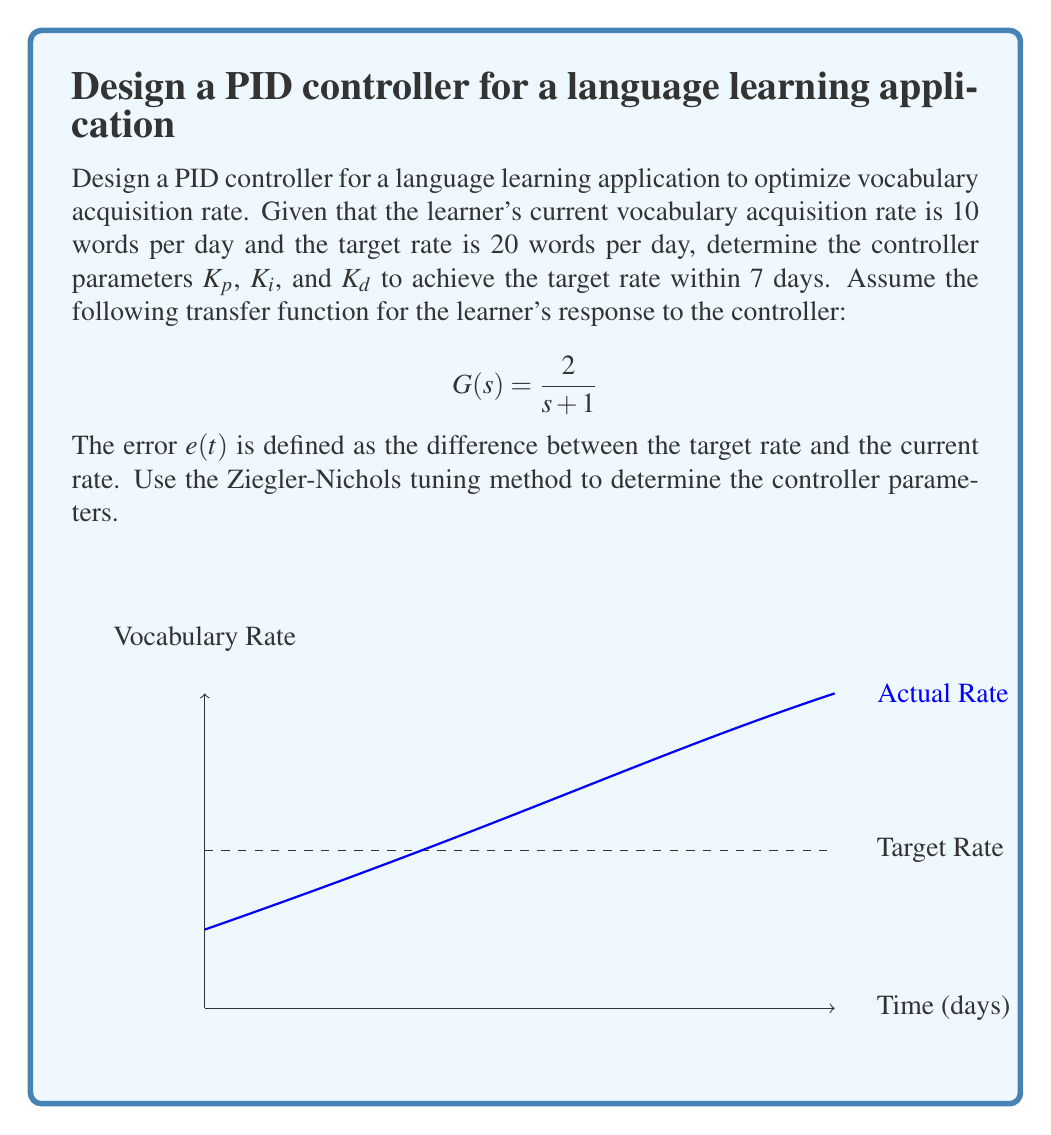Give your solution to this math problem. To design the PID controller, we'll follow these steps:

1. Determine the critical gain $K_u$ and critical period $T_u$ using the Ziegler-Nichols method:

   a. Set $K_i = K_d = 0$ and increase $K_p$ until the system oscillates.
   b. The gain at this point is $K_u$, and the period of oscillation is $T_u$.

2. For the given transfer function $G(s) = \frac{2}{s + 1}$, we can find $K_u$ analytically:

   $K_u = \frac{1}{2} = 0.5$

   The critical period $T_u$ can be calculated as:

   $T_u = 2\pi\sqrt{\frac{1}{2}} = 4.44$ days

3. Use the Ziegler-Nichols tuning rules to determine $K_p$, $K_i$, and $K_d$:

   $K_p = 0.6K_u = 0.6 \times 0.5 = 0.3$
   $T_i = 0.5T_u = 0.5 \times 4.44 = 2.22$ days
   $T_d = 0.125T_u = 0.125 \times 4.44 = 0.555$ days

   $K_i = \frac{K_p}{T_i} = \frac{0.3}{2.22} = 0.135$ per day
   $K_d = K_p \times T_d = 0.3 \times 0.555 = 0.1665$ days

4. The PID controller transfer function is:

   $$C(s) = K_p + \frac{K_i}{s} + K_d s$$

5. Substituting the values:

   $$C(s) = 0.3 + \frac{0.135}{s} + 0.1665s$$

This PID controller should help achieve the target vocabulary acquisition rate of 20 words per day within the specified 7-day period.
Answer: $K_p = 0.3$, $K_i = 0.135$ per day, $K_d = 0.1665$ days 